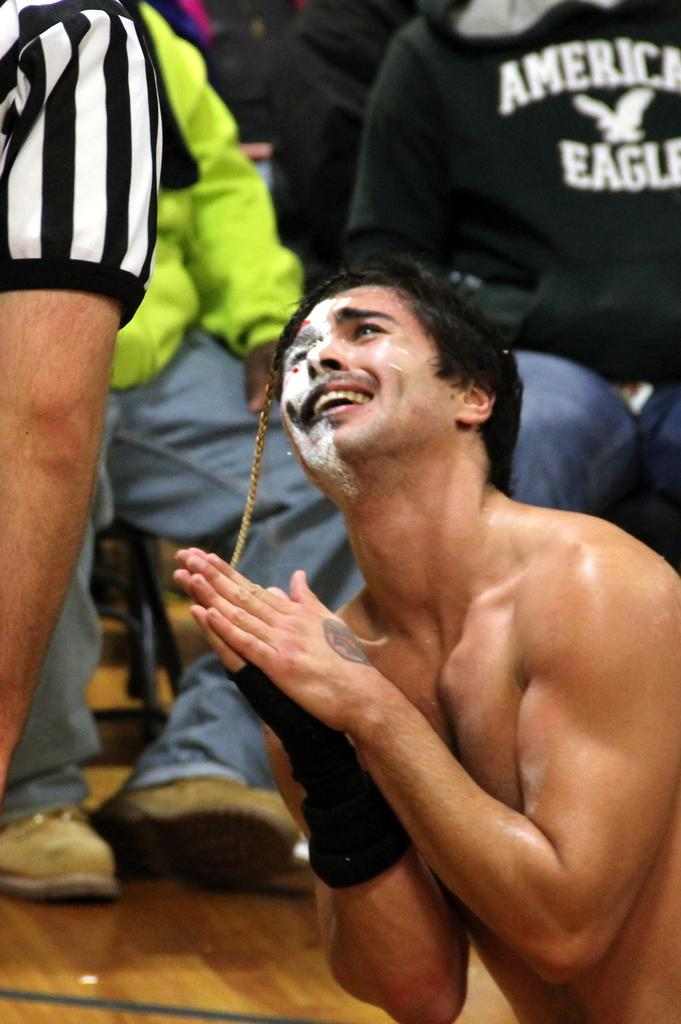<image>
Render a clear and concise summary of the photo. a shirt that has the word American on it 